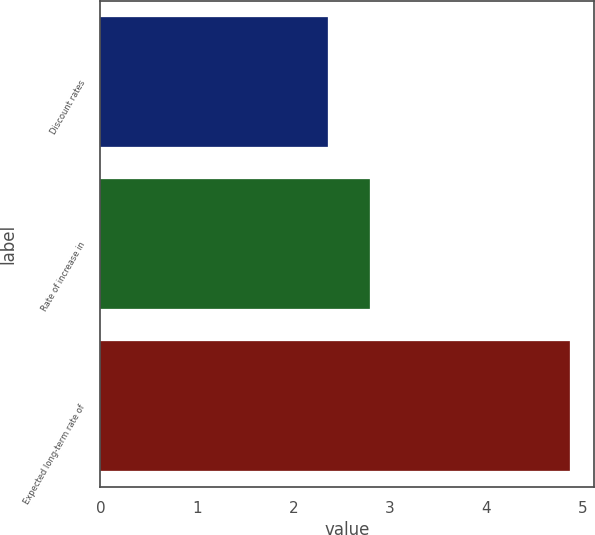Convert chart. <chart><loc_0><loc_0><loc_500><loc_500><bar_chart><fcel>Discount rates<fcel>Rate of increase in<fcel>Expected long-term rate of<nl><fcel>2.36<fcel>2.8<fcel>4.87<nl></chart> 